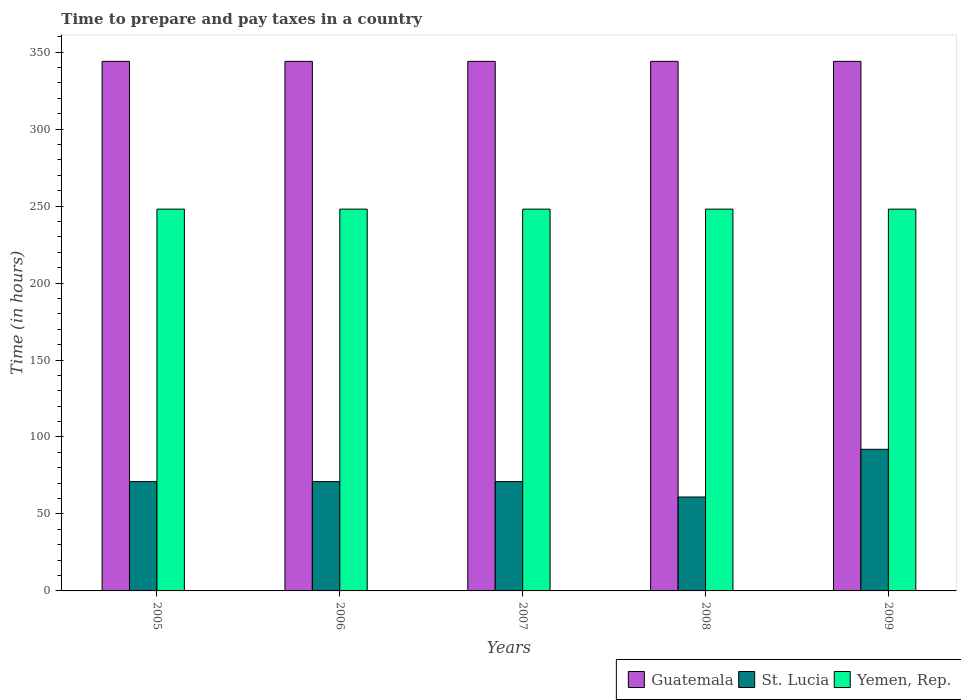How many different coloured bars are there?
Provide a succinct answer. 3. How many groups of bars are there?
Offer a very short reply. 5. What is the label of the 1st group of bars from the left?
Your answer should be very brief. 2005. In how many cases, is the number of bars for a given year not equal to the number of legend labels?
Keep it short and to the point. 0. What is the number of hours required to prepare and pay taxes in St. Lucia in 2007?
Your response must be concise. 71. Across all years, what is the maximum number of hours required to prepare and pay taxes in Guatemala?
Offer a terse response. 344. In which year was the number of hours required to prepare and pay taxes in St. Lucia minimum?
Your answer should be compact. 2008. What is the total number of hours required to prepare and pay taxes in St. Lucia in the graph?
Offer a terse response. 366. What is the difference between the number of hours required to prepare and pay taxes in Guatemala in 2005 and that in 2009?
Keep it short and to the point. 0. What is the difference between the number of hours required to prepare and pay taxes in Guatemala in 2007 and the number of hours required to prepare and pay taxes in Yemen, Rep. in 2006?
Your answer should be very brief. 96. What is the average number of hours required to prepare and pay taxes in Guatemala per year?
Make the answer very short. 344. In the year 2009, what is the difference between the number of hours required to prepare and pay taxes in St. Lucia and number of hours required to prepare and pay taxes in Yemen, Rep.?
Your answer should be very brief. -156. In how many years, is the number of hours required to prepare and pay taxes in Yemen, Rep. greater than 230 hours?
Offer a terse response. 5. Is the difference between the number of hours required to prepare and pay taxes in St. Lucia in 2005 and 2006 greater than the difference between the number of hours required to prepare and pay taxes in Yemen, Rep. in 2005 and 2006?
Ensure brevity in your answer.  No. Is the sum of the number of hours required to prepare and pay taxes in St. Lucia in 2007 and 2008 greater than the maximum number of hours required to prepare and pay taxes in Yemen, Rep. across all years?
Your response must be concise. No. What does the 2nd bar from the left in 2007 represents?
Provide a succinct answer. St. Lucia. What does the 3rd bar from the right in 2008 represents?
Provide a succinct answer. Guatemala. How many bars are there?
Offer a very short reply. 15. Are all the bars in the graph horizontal?
Offer a terse response. No. Does the graph contain any zero values?
Your answer should be compact. No. What is the title of the graph?
Your answer should be compact. Time to prepare and pay taxes in a country. Does "Greenland" appear as one of the legend labels in the graph?
Give a very brief answer. No. What is the label or title of the Y-axis?
Your answer should be compact. Time (in hours). What is the Time (in hours) in Guatemala in 2005?
Ensure brevity in your answer.  344. What is the Time (in hours) of St. Lucia in 2005?
Your answer should be compact. 71. What is the Time (in hours) in Yemen, Rep. in 2005?
Provide a succinct answer. 248. What is the Time (in hours) in Guatemala in 2006?
Keep it short and to the point. 344. What is the Time (in hours) of Yemen, Rep. in 2006?
Ensure brevity in your answer.  248. What is the Time (in hours) of Guatemala in 2007?
Offer a terse response. 344. What is the Time (in hours) of Yemen, Rep. in 2007?
Provide a succinct answer. 248. What is the Time (in hours) in Guatemala in 2008?
Ensure brevity in your answer.  344. What is the Time (in hours) of St. Lucia in 2008?
Your answer should be compact. 61. What is the Time (in hours) of Yemen, Rep. in 2008?
Provide a succinct answer. 248. What is the Time (in hours) of Guatemala in 2009?
Your answer should be compact. 344. What is the Time (in hours) of St. Lucia in 2009?
Give a very brief answer. 92. What is the Time (in hours) of Yemen, Rep. in 2009?
Provide a short and direct response. 248. Across all years, what is the maximum Time (in hours) of Guatemala?
Give a very brief answer. 344. Across all years, what is the maximum Time (in hours) of St. Lucia?
Give a very brief answer. 92. Across all years, what is the maximum Time (in hours) in Yemen, Rep.?
Your answer should be very brief. 248. Across all years, what is the minimum Time (in hours) in Guatemala?
Offer a very short reply. 344. Across all years, what is the minimum Time (in hours) in Yemen, Rep.?
Keep it short and to the point. 248. What is the total Time (in hours) of Guatemala in the graph?
Give a very brief answer. 1720. What is the total Time (in hours) in St. Lucia in the graph?
Provide a succinct answer. 366. What is the total Time (in hours) in Yemen, Rep. in the graph?
Provide a succinct answer. 1240. What is the difference between the Time (in hours) of St. Lucia in 2005 and that in 2006?
Give a very brief answer. 0. What is the difference between the Time (in hours) in Yemen, Rep. in 2005 and that in 2006?
Provide a succinct answer. 0. What is the difference between the Time (in hours) in St. Lucia in 2005 and that in 2007?
Keep it short and to the point. 0. What is the difference between the Time (in hours) of Yemen, Rep. in 2005 and that in 2007?
Offer a very short reply. 0. What is the difference between the Time (in hours) of Yemen, Rep. in 2005 and that in 2009?
Make the answer very short. 0. What is the difference between the Time (in hours) of Yemen, Rep. in 2006 and that in 2007?
Ensure brevity in your answer.  0. What is the difference between the Time (in hours) of Yemen, Rep. in 2006 and that in 2008?
Keep it short and to the point. 0. What is the difference between the Time (in hours) of St. Lucia in 2006 and that in 2009?
Ensure brevity in your answer.  -21. What is the difference between the Time (in hours) of Yemen, Rep. in 2006 and that in 2009?
Keep it short and to the point. 0. What is the difference between the Time (in hours) in Guatemala in 2007 and that in 2009?
Your answer should be compact. 0. What is the difference between the Time (in hours) of St. Lucia in 2007 and that in 2009?
Your answer should be very brief. -21. What is the difference between the Time (in hours) of St. Lucia in 2008 and that in 2009?
Provide a short and direct response. -31. What is the difference between the Time (in hours) of Guatemala in 2005 and the Time (in hours) of St. Lucia in 2006?
Your answer should be compact. 273. What is the difference between the Time (in hours) in Guatemala in 2005 and the Time (in hours) in Yemen, Rep. in 2006?
Offer a terse response. 96. What is the difference between the Time (in hours) in St. Lucia in 2005 and the Time (in hours) in Yemen, Rep. in 2006?
Your response must be concise. -177. What is the difference between the Time (in hours) in Guatemala in 2005 and the Time (in hours) in St. Lucia in 2007?
Make the answer very short. 273. What is the difference between the Time (in hours) of Guatemala in 2005 and the Time (in hours) of Yemen, Rep. in 2007?
Provide a succinct answer. 96. What is the difference between the Time (in hours) in St. Lucia in 2005 and the Time (in hours) in Yemen, Rep. in 2007?
Offer a terse response. -177. What is the difference between the Time (in hours) in Guatemala in 2005 and the Time (in hours) in St. Lucia in 2008?
Keep it short and to the point. 283. What is the difference between the Time (in hours) of Guatemala in 2005 and the Time (in hours) of Yemen, Rep. in 2008?
Offer a very short reply. 96. What is the difference between the Time (in hours) of St. Lucia in 2005 and the Time (in hours) of Yemen, Rep. in 2008?
Your answer should be very brief. -177. What is the difference between the Time (in hours) of Guatemala in 2005 and the Time (in hours) of St. Lucia in 2009?
Provide a succinct answer. 252. What is the difference between the Time (in hours) in Guatemala in 2005 and the Time (in hours) in Yemen, Rep. in 2009?
Keep it short and to the point. 96. What is the difference between the Time (in hours) of St. Lucia in 2005 and the Time (in hours) of Yemen, Rep. in 2009?
Give a very brief answer. -177. What is the difference between the Time (in hours) in Guatemala in 2006 and the Time (in hours) in St. Lucia in 2007?
Make the answer very short. 273. What is the difference between the Time (in hours) of Guatemala in 2006 and the Time (in hours) of Yemen, Rep. in 2007?
Your answer should be compact. 96. What is the difference between the Time (in hours) of St. Lucia in 2006 and the Time (in hours) of Yemen, Rep. in 2007?
Keep it short and to the point. -177. What is the difference between the Time (in hours) of Guatemala in 2006 and the Time (in hours) of St. Lucia in 2008?
Give a very brief answer. 283. What is the difference between the Time (in hours) in Guatemala in 2006 and the Time (in hours) in Yemen, Rep. in 2008?
Ensure brevity in your answer.  96. What is the difference between the Time (in hours) of St. Lucia in 2006 and the Time (in hours) of Yemen, Rep. in 2008?
Make the answer very short. -177. What is the difference between the Time (in hours) in Guatemala in 2006 and the Time (in hours) in St. Lucia in 2009?
Ensure brevity in your answer.  252. What is the difference between the Time (in hours) in Guatemala in 2006 and the Time (in hours) in Yemen, Rep. in 2009?
Offer a very short reply. 96. What is the difference between the Time (in hours) of St. Lucia in 2006 and the Time (in hours) of Yemen, Rep. in 2009?
Provide a short and direct response. -177. What is the difference between the Time (in hours) in Guatemala in 2007 and the Time (in hours) in St. Lucia in 2008?
Provide a succinct answer. 283. What is the difference between the Time (in hours) in Guatemala in 2007 and the Time (in hours) in Yemen, Rep. in 2008?
Ensure brevity in your answer.  96. What is the difference between the Time (in hours) of St. Lucia in 2007 and the Time (in hours) of Yemen, Rep. in 2008?
Your answer should be compact. -177. What is the difference between the Time (in hours) of Guatemala in 2007 and the Time (in hours) of St. Lucia in 2009?
Your answer should be very brief. 252. What is the difference between the Time (in hours) of Guatemala in 2007 and the Time (in hours) of Yemen, Rep. in 2009?
Offer a terse response. 96. What is the difference between the Time (in hours) of St. Lucia in 2007 and the Time (in hours) of Yemen, Rep. in 2009?
Provide a short and direct response. -177. What is the difference between the Time (in hours) in Guatemala in 2008 and the Time (in hours) in St. Lucia in 2009?
Provide a succinct answer. 252. What is the difference between the Time (in hours) of Guatemala in 2008 and the Time (in hours) of Yemen, Rep. in 2009?
Keep it short and to the point. 96. What is the difference between the Time (in hours) in St. Lucia in 2008 and the Time (in hours) in Yemen, Rep. in 2009?
Keep it short and to the point. -187. What is the average Time (in hours) in Guatemala per year?
Give a very brief answer. 344. What is the average Time (in hours) of St. Lucia per year?
Offer a very short reply. 73.2. What is the average Time (in hours) in Yemen, Rep. per year?
Keep it short and to the point. 248. In the year 2005, what is the difference between the Time (in hours) in Guatemala and Time (in hours) in St. Lucia?
Make the answer very short. 273. In the year 2005, what is the difference between the Time (in hours) of Guatemala and Time (in hours) of Yemen, Rep.?
Your answer should be compact. 96. In the year 2005, what is the difference between the Time (in hours) in St. Lucia and Time (in hours) in Yemen, Rep.?
Provide a succinct answer. -177. In the year 2006, what is the difference between the Time (in hours) in Guatemala and Time (in hours) in St. Lucia?
Provide a succinct answer. 273. In the year 2006, what is the difference between the Time (in hours) in Guatemala and Time (in hours) in Yemen, Rep.?
Your answer should be very brief. 96. In the year 2006, what is the difference between the Time (in hours) in St. Lucia and Time (in hours) in Yemen, Rep.?
Ensure brevity in your answer.  -177. In the year 2007, what is the difference between the Time (in hours) in Guatemala and Time (in hours) in St. Lucia?
Your response must be concise. 273. In the year 2007, what is the difference between the Time (in hours) of Guatemala and Time (in hours) of Yemen, Rep.?
Your answer should be very brief. 96. In the year 2007, what is the difference between the Time (in hours) in St. Lucia and Time (in hours) in Yemen, Rep.?
Your answer should be compact. -177. In the year 2008, what is the difference between the Time (in hours) in Guatemala and Time (in hours) in St. Lucia?
Provide a succinct answer. 283. In the year 2008, what is the difference between the Time (in hours) of Guatemala and Time (in hours) of Yemen, Rep.?
Your response must be concise. 96. In the year 2008, what is the difference between the Time (in hours) of St. Lucia and Time (in hours) of Yemen, Rep.?
Keep it short and to the point. -187. In the year 2009, what is the difference between the Time (in hours) in Guatemala and Time (in hours) in St. Lucia?
Give a very brief answer. 252. In the year 2009, what is the difference between the Time (in hours) in Guatemala and Time (in hours) in Yemen, Rep.?
Your response must be concise. 96. In the year 2009, what is the difference between the Time (in hours) of St. Lucia and Time (in hours) of Yemen, Rep.?
Your answer should be compact. -156. What is the ratio of the Time (in hours) of Guatemala in 2005 to that in 2006?
Keep it short and to the point. 1. What is the ratio of the Time (in hours) in St. Lucia in 2005 to that in 2006?
Offer a terse response. 1. What is the ratio of the Time (in hours) of Yemen, Rep. in 2005 to that in 2006?
Provide a succinct answer. 1. What is the ratio of the Time (in hours) in Guatemala in 2005 to that in 2007?
Ensure brevity in your answer.  1. What is the ratio of the Time (in hours) of Yemen, Rep. in 2005 to that in 2007?
Ensure brevity in your answer.  1. What is the ratio of the Time (in hours) of St. Lucia in 2005 to that in 2008?
Your answer should be very brief. 1.16. What is the ratio of the Time (in hours) in Guatemala in 2005 to that in 2009?
Ensure brevity in your answer.  1. What is the ratio of the Time (in hours) of St. Lucia in 2005 to that in 2009?
Make the answer very short. 0.77. What is the ratio of the Time (in hours) in Guatemala in 2006 to that in 2007?
Your response must be concise. 1. What is the ratio of the Time (in hours) of Yemen, Rep. in 2006 to that in 2007?
Give a very brief answer. 1. What is the ratio of the Time (in hours) of St. Lucia in 2006 to that in 2008?
Provide a short and direct response. 1.16. What is the ratio of the Time (in hours) in Yemen, Rep. in 2006 to that in 2008?
Give a very brief answer. 1. What is the ratio of the Time (in hours) in Guatemala in 2006 to that in 2009?
Ensure brevity in your answer.  1. What is the ratio of the Time (in hours) of St. Lucia in 2006 to that in 2009?
Keep it short and to the point. 0.77. What is the ratio of the Time (in hours) in Yemen, Rep. in 2006 to that in 2009?
Make the answer very short. 1. What is the ratio of the Time (in hours) of Guatemala in 2007 to that in 2008?
Give a very brief answer. 1. What is the ratio of the Time (in hours) in St. Lucia in 2007 to that in 2008?
Your answer should be compact. 1.16. What is the ratio of the Time (in hours) of Yemen, Rep. in 2007 to that in 2008?
Offer a terse response. 1. What is the ratio of the Time (in hours) in St. Lucia in 2007 to that in 2009?
Give a very brief answer. 0.77. What is the ratio of the Time (in hours) in Guatemala in 2008 to that in 2009?
Ensure brevity in your answer.  1. What is the ratio of the Time (in hours) in St. Lucia in 2008 to that in 2009?
Offer a very short reply. 0.66. What is the difference between the highest and the lowest Time (in hours) in Guatemala?
Offer a very short reply. 0. What is the difference between the highest and the lowest Time (in hours) in Yemen, Rep.?
Your response must be concise. 0. 